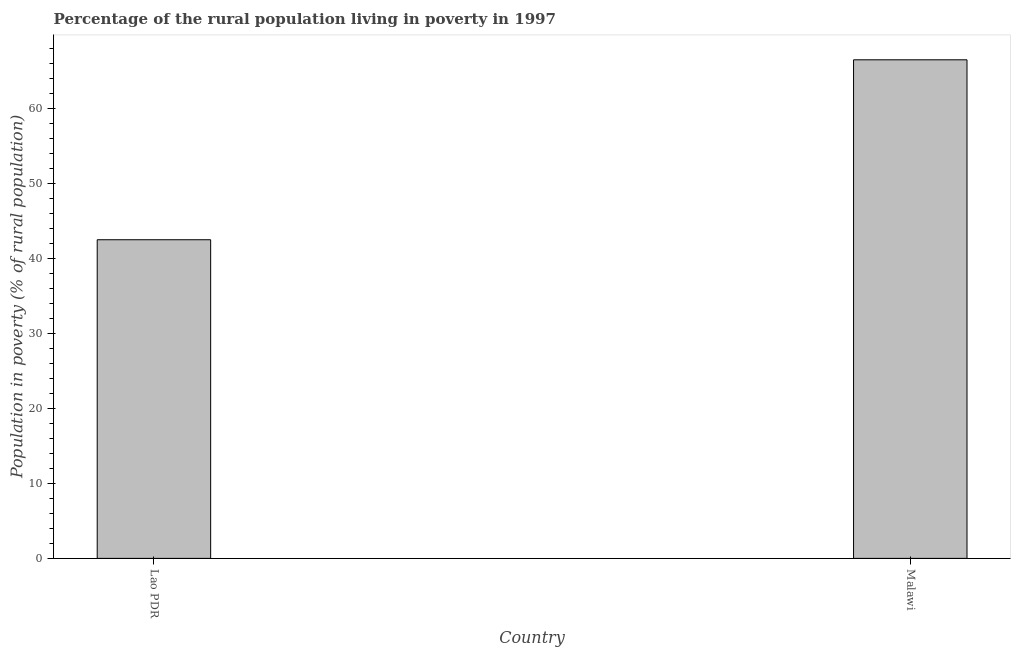Does the graph contain any zero values?
Ensure brevity in your answer.  No. What is the title of the graph?
Make the answer very short. Percentage of the rural population living in poverty in 1997. What is the label or title of the Y-axis?
Ensure brevity in your answer.  Population in poverty (% of rural population). What is the percentage of rural population living below poverty line in Lao PDR?
Your response must be concise. 42.5. Across all countries, what is the maximum percentage of rural population living below poverty line?
Your answer should be very brief. 66.5. Across all countries, what is the minimum percentage of rural population living below poverty line?
Provide a short and direct response. 42.5. In which country was the percentage of rural population living below poverty line maximum?
Your answer should be compact. Malawi. In which country was the percentage of rural population living below poverty line minimum?
Provide a short and direct response. Lao PDR. What is the sum of the percentage of rural population living below poverty line?
Offer a very short reply. 109. What is the difference between the percentage of rural population living below poverty line in Lao PDR and Malawi?
Keep it short and to the point. -24. What is the average percentage of rural population living below poverty line per country?
Your answer should be very brief. 54.5. What is the median percentage of rural population living below poverty line?
Ensure brevity in your answer.  54.5. In how many countries, is the percentage of rural population living below poverty line greater than 30 %?
Keep it short and to the point. 2. What is the ratio of the percentage of rural population living below poverty line in Lao PDR to that in Malawi?
Ensure brevity in your answer.  0.64. How many bars are there?
Provide a short and direct response. 2. What is the Population in poverty (% of rural population) in Lao PDR?
Give a very brief answer. 42.5. What is the Population in poverty (% of rural population) of Malawi?
Your answer should be very brief. 66.5. What is the difference between the Population in poverty (% of rural population) in Lao PDR and Malawi?
Provide a short and direct response. -24. What is the ratio of the Population in poverty (% of rural population) in Lao PDR to that in Malawi?
Ensure brevity in your answer.  0.64. 